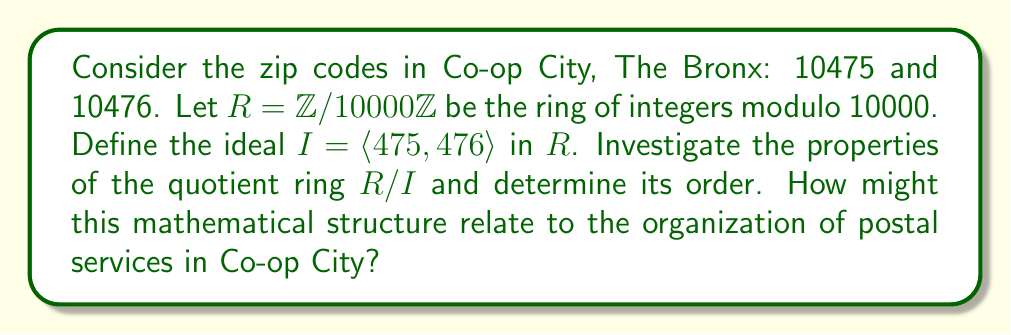Can you solve this math problem? Let's approach this step-by-step:

1) First, we need to understand what the ideal $I = \langle 475, 476 \rangle$ represents in $R = \mathbb{Z}/10000\mathbb{Z}$. It's the set of all linear combinations of 475 and 476 in $R$.

2) To find the order of $R/I$, we need to find the size of the ideal $I$. This is equivalent to finding the greatest common divisor (gcd) of 475, 476, and 10000.

3) Let's compute the gcd:
   $gcd(475, 476) = 1$
   $gcd(1, 10000) = 1$

4) Since the gcd is 1, the ideal $I$ is actually the entire ring $R$. This means that 475 and 476 generate all of $R$.

5) Therefore, $R/I$ is the trivial ring with only one element, often denoted as $\{0\}$.

6) The order of $R/I$ is thus 1.

Relating this to Co-op City:
The fact that the quotient ring has only one element suggests that, mathematically, the two zip codes are "equivalent" in the context of this ring structure. This could be interpreted as reflecting the unified nature of Co-op City despite having two zip codes. It emphasizes the community's cohesion, which aligns with the cooperative spirit of the neighborhood.

For Michael Benedetto, a supporter and likely advocate for Co-op City, this mathematical insight could be used to reinforce the idea of unity and shared identity among residents, regardless of their specific zip code within Co-op City.
Answer: The order of the quotient ring $R/I$ is 1. It is the trivial ring with only one element. 